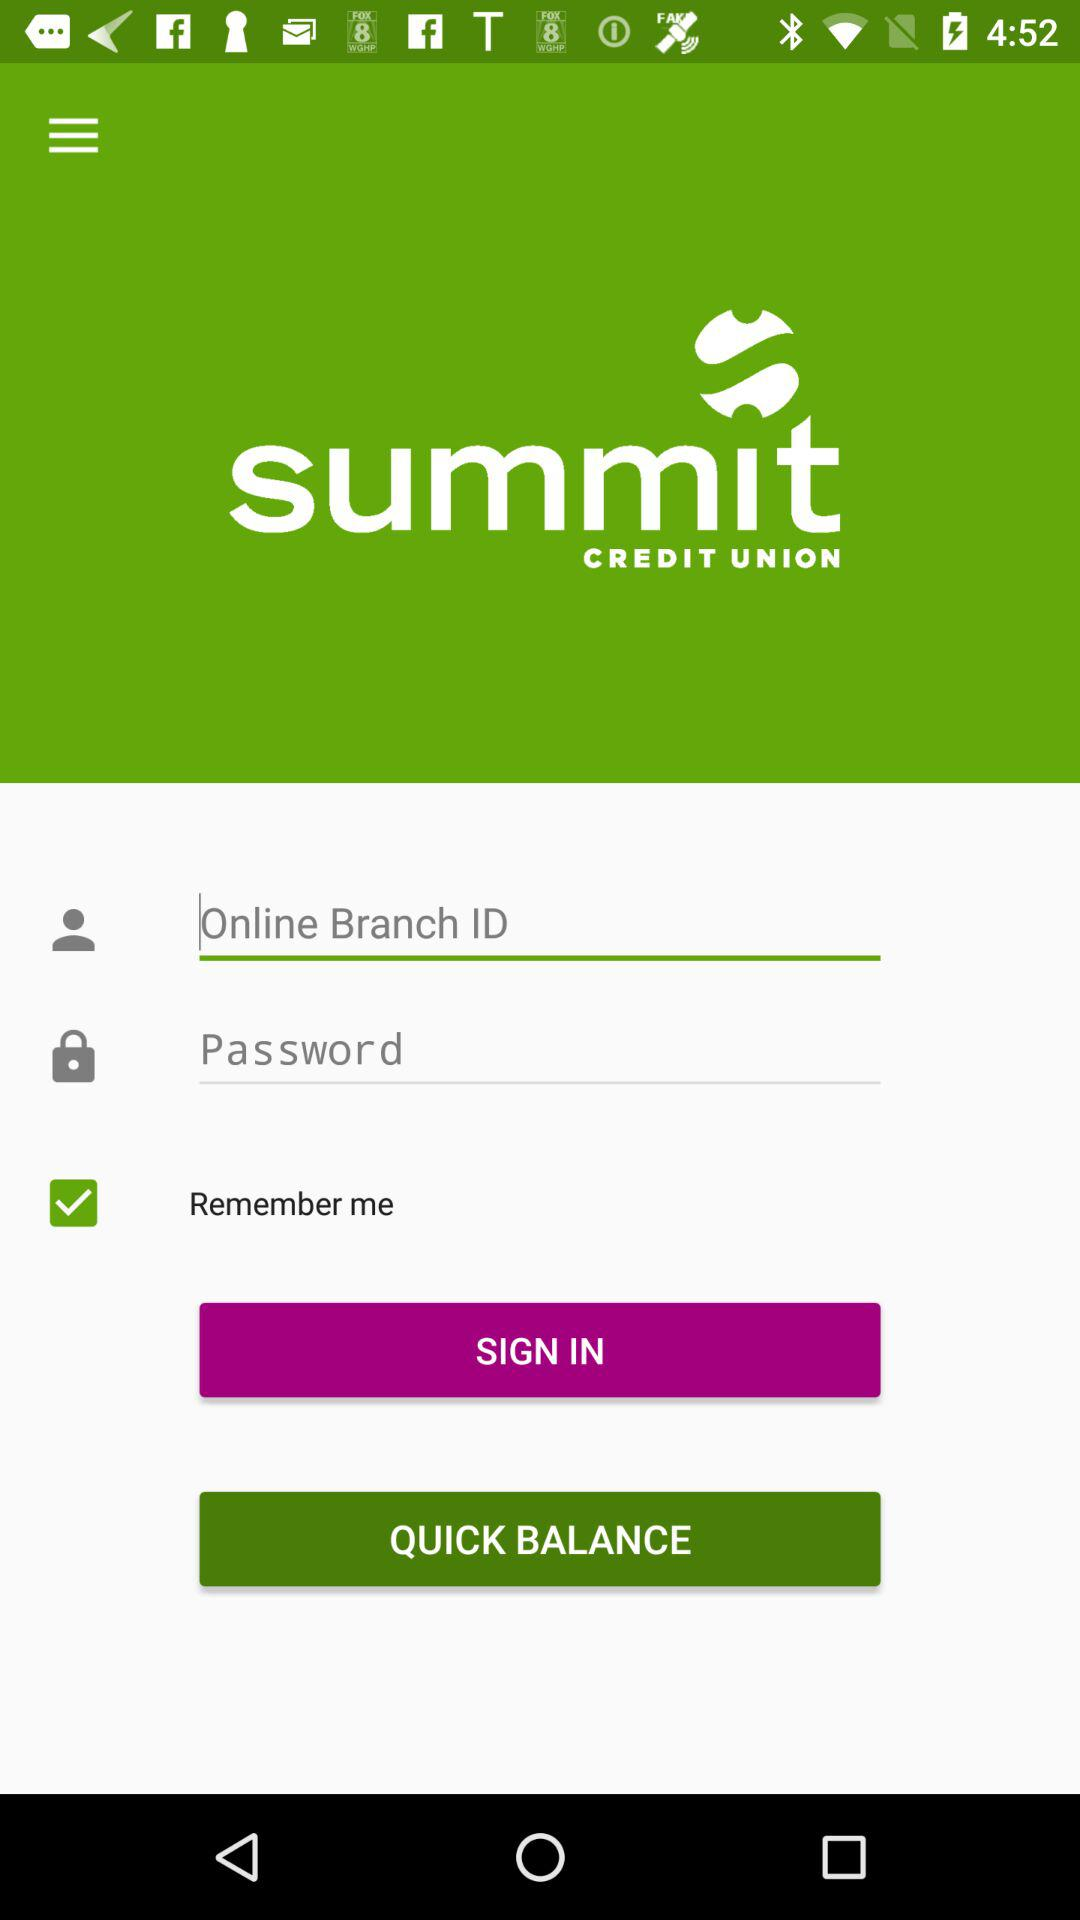How many text fields are there on the sign in screen?
Answer the question using a single word or phrase. 2 